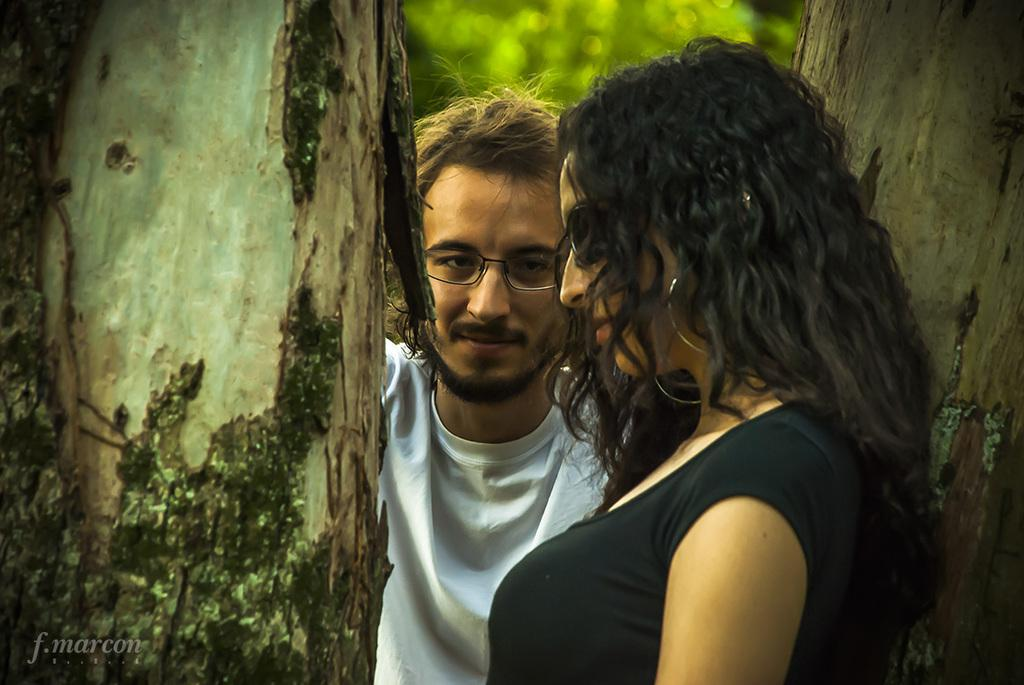Who is present in the image? There is a woman and a man wearing spectacles in the image. What is the man doing in the image? The man is smiling in the image. What can be seen beside the man and woman? Tree trunks are visible beside the man and woman. What is visible in the background of the image? Leaves are present in the background of the image. How would you describe the background of the image? The background appears blurry. What type of match is being played in the image? There is no match being played in the image; it features a woman and a man with a blurry background. Can you see any steam coming from the man's cup in the image? There is no cup or steam present in the image. 